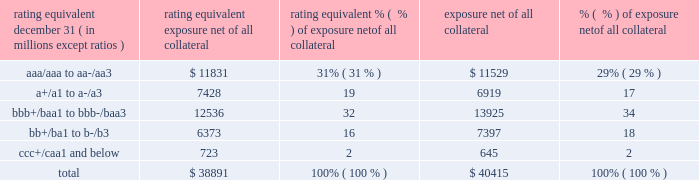Management 2019s discussion and analysis 118 jpmorgan chase & co./2018 form 10-k equivalent to the risk of loan exposures .
Dre is a less extreme measure of potential credit loss than peak and is used as an input for aggregating derivative credit risk exposures with loans and other credit risk .
Finally , avg is a measure of the expected fair value of the firm 2019s derivative receivables at future time periods , including the benefit of collateral .
Avg over the total life of the derivative contract is used as the primary metric for pricing purposes and is used to calculate credit risk capital and the cva , as further described below .
The fair value of the firm 2019s derivative receivables incorporates cva to reflect the credit quality of counterparties .
Cva is based on the firm 2019s avg to a counterparty and the counterparty 2019s credit spread in the credit derivatives market .
The firm believes that active risk management is essential to controlling the dynamic credit risk in the derivatives portfolio .
In addition , the firm 2019s risk management process takes into consideration the potential impact of wrong-way risk , which is broadly defined as the potential for increased correlation between the firm 2019s exposure to a counterparty ( avg ) and the counterparty 2019s credit quality .
Many factors may influence the nature and magnitude of these correlations over time .
To the extent that these correlations are identified , the firm may adjust the cva associated with that counterparty 2019s avg .
The firm risk manages exposure to changes in cva by entering into credit derivative contracts , as well as interest rate , foreign exchange , equity and commodity derivative contracts .
The accompanying graph shows exposure profiles to the firm 2019s current derivatives portfolio over the next 10 years as calculated by the peak , dre and avg metrics .
The three measures generally show that exposure will decline after the first year , if no new trades are added to the portfolio .
Exposure profile of derivatives measures december 31 , 2018 ( in billions ) the table summarizes the ratings profile of the firm 2019s derivative receivables , including credit derivatives , net of all collateral , at the dates indicated .
The ratings scale is based on the firm 2019s internal ratings , which generally correspond to the ratings as assigned by s&p and moody 2019s .
Ratings profile of derivative receivables .
As previously noted , the firm uses collateral agreements to mitigate counterparty credit risk .
The percentage of the firm 2019s over-the-counter derivative transactions subject to collateral agreements 2014 excluding foreign exchange spot trades , which are not typically covered by collateral agreements due to their short maturity and centrally cleared trades that are settled daily 2014 was approximately 90% ( 90 % ) at both december 31 , 2018 , and december 31 , 2017. .
What is the percentual fluctuation of the aaa/aaa to aa-/aa3's exposure net of all collateral in relation with the bb+/ba1 to b-/b3 during 2017 and 2018? 
Rationale: its the difference between those percentual variations during 2017 and 2018 .
Computations: ((18 - 16) - (29% - 31%))
Answer: 2.02. 